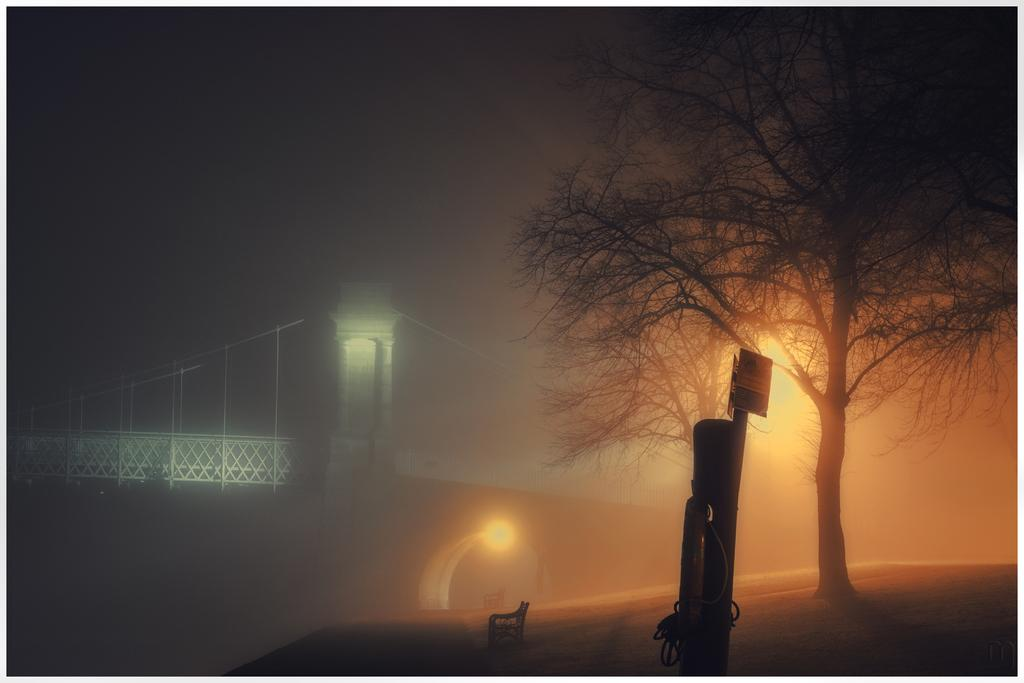What type of seating is visible in the image? There is a bench in the image. What type of plant is present in the image? There is a tree in the image. What material is present in the image? There are boards in the image. What type of illumination is present in the image? There are lights in the image. What type of structure can be seen in the background of the image? There is a bridge in the background of the image. How would you describe the lighting conditions in the image? The image appears to be slightly dark. What type of school can be seen in the image? There is no school present in the image. What type of milk is being served on the bench in the image? There is no milk present in the image. What type of pig is visible near the tree in the image? There is no pig present in the image. 